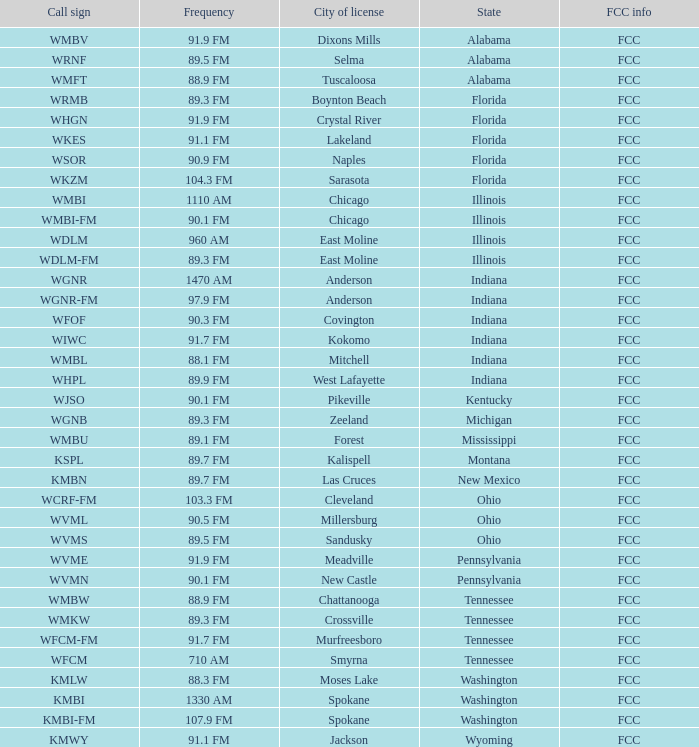In which city is 10 Cleveland. 